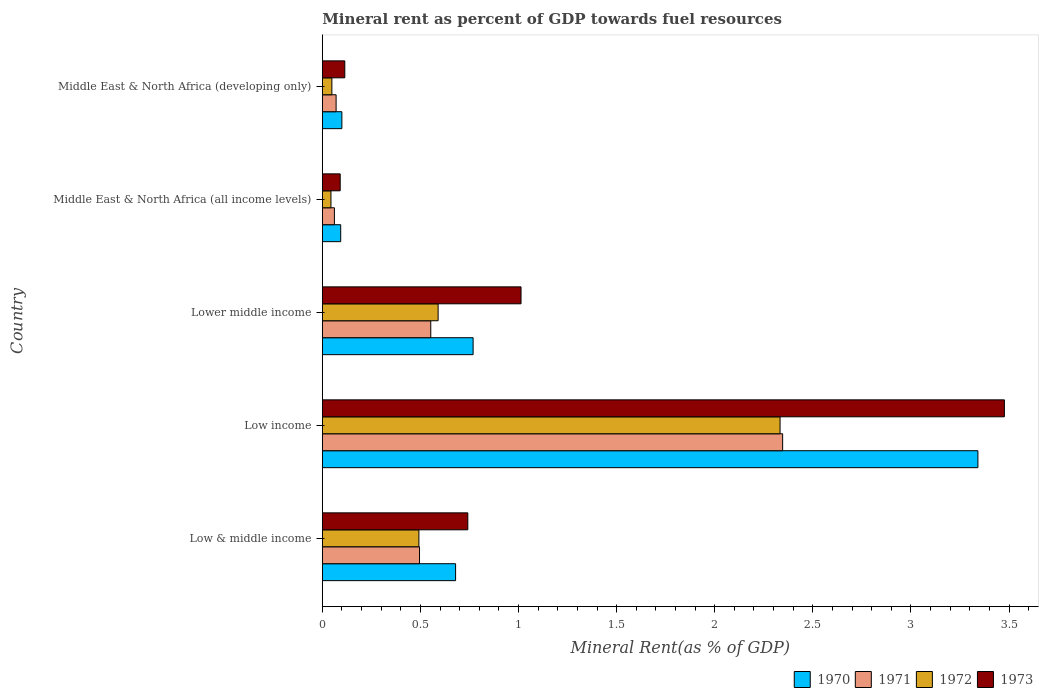How many different coloured bars are there?
Provide a short and direct response. 4. Are the number of bars per tick equal to the number of legend labels?
Your response must be concise. Yes. How many bars are there on the 3rd tick from the top?
Your response must be concise. 4. How many bars are there on the 5th tick from the bottom?
Offer a very short reply. 4. What is the label of the 1st group of bars from the top?
Keep it short and to the point. Middle East & North Africa (developing only). What is the mineral rent in 1972 in Low & middle income?
Offer a terse response. 0.49. Across all countries, what is the maximum mineral rent in 1972?
Offer a very short reply. 2.33. Across all countries, what is the minimum mineral rent in 1973?
Ensure brevity in your answer.  0.09. In which country was the mineral rent in 1971 minimum?
Provide a short and direct response. Middle East & North Africa (all income levels). What is the total mineral rent in 1971 in the graph?
Your response must be concise. 3.53. What is the difference between the mineral rent in 1970 in Low income and that in Lower middle income?
Provide a succinct answer. 2.57. What is the difference between the mineral rent in 1973 in Low income and the mineral rent in 1972 in Low & middle income?
Your response must be concise. 2.98. What is the average mineral rent in 1972 per country?
Offer a terse response. 0.7. What is the difference between the mineral rent in 1970 and mineral rent in 1972 in Middle East & North Africa (all income levels)?
Your answer should be compact. 0.05. What is the ratio of the mineral rent in 1972 in Low income to that in Middle East & North Africa (developing only)?
Provide a succinct answer. 47.95. Is the difference between the mineral rent in 1970 in Low income and Middle East & North Africa (all income levels) greater than the difference between the mineral rent in 1972 in Low income and Middle East & North Africa (all income levels)?
Offer a terse response. Yes. What is the difference between the highest and the second highest mineral rent in 1973?
Give a very brief answer. 2.46. What is the difference between the highest and the lowest mineral rent in 1973?
Your answer should be very brief. 3.39. Is the sum of the mineral rent in 1973 in Low & middle income and Low income greater than the maximum mineral rent in 1972 across all countries?
Offer a very short reply. Yes. What does the 3rd bar from the bottom in Middle East & North Africa (developing only) represents?
Offer a terse response. 1972. How many bars are there?
Provide a short and direct response. 20. Are all the bars in the graph horizontal?
Make the answer very short. Yes. How many countries are there in the graph?
Provide a short and direct response. 5. Does the graph contain any zero values?
Provide a short and direct response. No. Does the graph contain grids?
Offer a terse response. No. Where does the legend appear in the graph?
Provide a short and direct response. Bottom right. How many legend labels are there?
Ensure brevity in your answer.  4. How are the legend labels stacked?
Your response must be concise. Horizontal. What is the title of the graph?
Offer a terse response. Mineral rent as percent of GDP towards fuel resources. What is the label or title of the X-axis?
Give a very brief answer. Mineral Rent(as % of GDP). What is the label or title of the Y-axis?
Give a very brief answer. Country. What is the Mineral Rent(as % of GDP) of 1970 in Low & middle income?
Your response must be concise. 0.68. What is the Mineral Rent(as % of GDP) of 1971 in Low & middle income?
Your answer should be compact. 0.5. What is the Mineral Rent(as % of GDP) of 1972 in Low & middle income?
Your response must be concise. 0.49. What is the Mineral Rent(as % of GDP) in 1973 in Low & middle income?
Keep it short and to the point. 0.74. What is the Mineral Rent(as % of GDP) of 1970 in Low income?
Ensure brevity in your answer.  3.34. What is the Mineral Rent(as % of GDP) in 1971 in Low income?
Keep it short and to the point. 2.35. What is the Mineral Rent(as % of GDP) in 1972 in Low income?
Make the answer very short. 2.33. What is the Mineral Rent(as % of GDP) of 1973 in Low income?
Keep it short and to the point. 3.48. What is the Mineral Rent(as % of GDP) of 1970 in Lower middle income?
Ensure brevity in your answer.  0.77. What is the Mineral Rent(as % of GDP) in 1971 in Lower middle income?
Your answer should be very brief. 0.55. What is the Mineral Rent(as % of GDP) in 1972 in Lower middle income?
Provide a succinct answer. 0.59. What is the Mineral Rent(as % of GDP) in 1973 in Lower middle income?
Provide a succinct answer. 1.01. What is the Mineral Rent(as % of GDP) of 1970 in Middle East & North Africa (all income levels)?
Offer a very short reply. 0.09. What is the Mineral Rent(as % of GDP) in 1971 in Middle East & North Africa (all income levels)?
Offer a very short reply. 0.06. What is the Mineral Rent(as % of GDP) in 1972 in Middle East & North Africa (all income levels)?
Provide a short and direct response. 0.04. What is the Mineral Rent(as % of GDP) of 1973 in Middle East & North Africa (all income levels)?
Your response must be concise. 0.09. What is the Mineral Rent(as % of GDP) of 1970 in Middle East & North Africa (developing only)?
Provide a short and direct response. 0.1. What is the Mineral Rent(as % of GDP) of 1971 in Middle East & North Africa (developing only)?
Provide a succinct answer. 0.07. What is the Mineral Rent(as % of GDP) of 1972 in Middle East & North Africa (developing only)?
Make the answer very short. 0.05. What is the Mineral Rent(as % of GDP) of 1973 in Middle East & North Africa (developing only)?
Provide a succinct answer. 0.11. Across all countries, what is the maximum Mineral Rent(as % of GDP) in 1970?
Your answer should be very brief. 3.34. Across all countries, what is the maximum Mineral Rent(as % of GDP) in 1971?
Keep it short and to the point. 2.35. Across all countries, what is the maximum Mineral Rent(as % of GDP) in 1972?
Provide a succinct answer. 2.33. Across all countries, what is the maximum Mineral Rent(as % of GDP) of 1973?
Offer a very short reply. 3.48. Across all countries, what is the minimum Mineral Rent(as % of GDP) in 1970?
Offer a very short reply. 0.09. Across all countries, what is the minimum Mineral Rent(as % of GDP) of 1971?
Provide a short and direct response. 0.06. Across all countries, what is the minimum Mineral Rent(as % of GDP) of 1972?
Ensure brevity in your answer.  0.04. Across all countries, what is the minimum Mineral Rent(as % of GDP) in 1973?
Provide a succinct answer. 0.09. What is the total Mineral Rent(as % of GDP) in 1970 in the graph?
Make the answer very short. 4.98. What is the total Mineral Rent(as % of GDP) of 1971 in the graph?
Provide a succinct answer. 3.53. What is the total Mineral Rent(as % of GDP) in 1972 in the graph?
Your answer should be compact. 3.51. What is the total Mineral Rent(as % of GDP) in 1973 in the graph?
Ensure brevity in your answer.  5.44. What is the difference between the Mineral Rent(as % of GDP) in 1970 in Low & middle income and that in Low income?
Offer a very short reply. -2.66. What is the difference between the Mineral Rent(as % of GDP) of 1971 in Low & middle income and that in Low income?
Provide a short and direct response. -1.85. What is the difference between the Mineral Rent(as % of GDP) of 1972 in Low & middle income and that in Low income?
Ensure brevity in your answer.  -1.84. What is the difference between the Mineral Rent(as % of GDP) in 1973 in Low & middle income and that in Low income?
Your response must be concise. -2.73. What is the difference between the Mineral Rent(as % of GDP) of 1970 in Low & middle income and that in Lower middle income?
Provide a succinct answer. -0.09. What is the difference between the Mineral Rent(as % of GDP) of 1971 in Low & middle income and that in Lower middle income?
Your response must be concise. -0.06. What is the difference between the Mineral Rent(as % of GDP) in 1972 in Low & middle income and that in Lower middle income?
Offer a terse response. -0.1. What is the difference between the Mineral Rent(as % of GDP) in 1973 in Low & middle income and that in Lower middle income?
Make the answer very short. -0.27. What is the difference between the Mineral Rent(as % of GDP) in 1970 in Low & middle income and that in Middle East & North Africa (all income levels)?
Offer a very short reply. 0.59. What is the difference between the Mineral Rent(as % of GDP) in 1971 in Low & middle income and that in Middle East & North Africa (all income levels)?
Provide a short and direct response. 0.43. What is the difference between the Mineral Rent(as % of GDP) in 1972 in Low & middle income and that in Middle East & North Africa (all income levels)?
Your answer should be compact. 0.45. What is the difference between the Mineral Rent(as % of GDP) in 1973 in Low & middle income and that in Middle East & North Africa (all income levels)?
Keep it short and to the point. 0.65. What is the difference between the Mineral Rent(as % of GDP) of 1970 in Low & middle income and that in Middle East & North Africa (developing only)?
Provide a short and direct response. 0.58. What is the difference between the Mineral Rent(as % of GDP) in 1971 in Low & middle income and that in Middle East & North Africa (developing only)?
Provide a succinct answer. 0.43. What is the difference between the Mineral Rent(as % of GDP) of 1972 in Low & middle income and that in Middle East & North Africa (developing only)?
Your response must be concise. 0.44. What is the difference between the Mineral Rent(as % of GDP) in 1973 in Low & middle income and that in Middle East & North Africa (developing only)?
Your response must be concise. 0.63. What is the difference between the Mineral Rent(as % of GDP) of 1970 in Low income and that in Lower middle income?
Offer a terse response. 2.57. What is the difference between the Mineral Rent(as % of GDP) in 1971 in Low income and that in Lower middle income?
Provide a short and direct response. 1.79. What is the difference between the Mineral Rent(as % of GDP) of 1972 in Low income and that in Lower middle income?
Keep it short and to the point. 1.74. What is the difference between the Mineral Rent(as % of GDP) in 1973 in Low income and that in Lower middle income?
Give a very brief answer. 2.46. What is the difference between the Mineral Rent(as % of GDP) in 1970 in Low income and that in Middle East & North Africa (all income levels)?
Your answer should be very brief. 3.25. What is the difference between the Mineral Rent(as % of GDP) in 1971 in Low income and that in Middle East & North Africa (all income levels)?
Ensure brevity in your answer.  2.28. What is the difference between the Mineral Rent(as % of GDP) of 1972 in Low income and that in Middle East & North Africa (all income levels)?
Make the answer very short. 2.29. What is the difference between the Mineral Rent(as % of GDP) in 1973 in Low income and that in Middle East & North Africa (all income levels)?
Keep it short and to the point. 3.39. What is the difference between the Mineral Rent(as % of GDP) of 1970 in Low income and that in Middle East & North Africa (developing only)?
Provide a succinct answer. 3.24. What is the difference between the Mineral Rent(as % of GDP) of 1971 in Low income and that in Middle East & North Africa (developing only)?
Your answer should be compact. 2.28. What is the difference between the Mineral Rent(as % of GDP) of 1972 in Low income and that in Middle East & North Africa (developing only)?
Make the answer very short. 2.28. What is the difference between the Mineral Rent(as % of GDP) of 1973 in Low income and that in Middle East & North Africa (developing only)?
Your response must be concise. 3.36. What is the difference between the Mineral Rent(as % of GDP) of 1970 in Lower middle income and that in Middle East & North Africa (all income levels)?
Your answer should be very brief. 0.67. What is the difference between the Mineral Rent(as % of GDP) of 1971 in Lower middle income and that in Middle East & North Africa (all income levels)?
Your answer should be very brief. 0.49. What is the difference between the Mineral Rent(as % of GDP) in 1972 in Lower middle income and that in Middle East & North Africa (all income levels)?
Make the answer very short. 0.55. What is the difference between the Mineral Rent(as % of GDP) in 1973 in Lower middle income and that in Middle East & North Africa (all income levels)?
Ensure brevity in your answer.  0.92. What is the difference between the Mineral Rent(as % of GDP) of 1970 in Lower middle income and that in Middle East & North Africa (developing only)?
Provide a short and direct response. 0.67. What is the difference between the Mineral Rent(as % of GDP) in 1971 in Lower middle income and that in Middle East & North Africa (developing only)?
Ensure brevity in your answer.  0.48. What is the difference between the Mineral Rent(as % of GDP) in 1972 in Lower middle income and that in Middle East & North Africa (developing only)?
Provide a succinct answer. 0.54. What is the difference between the Mineral Rent(as % of GDP) of 1973 in Lower middle income and that in Middle East & North Africa (developing only)?
Provide a short and direct response. 0.9. What is the difference between the Mineral Rent(as % of GDP) of 1970 in Middle East & North Africa (all income levels) and that in Middle East & North Africa (developing only)?
Your response must be concise. -0.01. What is the difference between the Mineral Rent(as % of GDP) of 1971 in Middle East & North Africa (all income levels) and that in Middle East & North Africa (developing only)?
Ensure brevity in your answer.  -0.01. What is the difference between the Mineral Rent(as % of GDP) of 1972 in Middle East & North Africa (all income levels) and that in Middle East & North Africa (developing only)?
Keep it short and to the point. -0. What is the difference between the Mineral Rent(as % of GDP) of 1973 in Middle East & North Africa (all income levels) and that in Middle East & North Africa (developing only)?
Your answer should be compact. -0.02. What is the difference between the Mineral Rent(as % of GDP) in 1970 in Low & middle income and the Mineral Rent(as % of GDP) in 1971 in Low income?
Make the answer very short. -1.67. What is the difference between the Mineral Rent(as % of GDP) of 1970 in Low & middle income and the Mineral Rent(as % of GDP) of 1972 in Low income?
Provide a succinct answer. -1.65. What is the difference between the Mineral Rent(as % of GDP) of 1970 in Low & middle income and the Mineral Rent(as % of GDP) of 1973 in Low income?
Offer a very short reply. -2.8. What is the difference between the Mineral Rent(as % of GDP) in 1971 in Low & middle income and the Mineral Rent(as % of GDP) in 1972 in Low income?
Your response must be concise. -1.84. What is the difference between the Mineral Rent(as % of GDP) of 1971 in Low & middle income and the Mineral Rent(as % of GDP) of 1973 in Low income?
Provide a short and direct response. -2.98. What is the difference between the Mineral Rent(as % of GDP) of 1972 in Low & middle income and the Mineral Rent(as % of GDP) of 1973 in Low income?
Keep it short and to the point. -2.98. What is the difference between the Mineral Rent(as % of GDP) in 1970 in Low & middle income and the Mineral Rent(as % of GDP) in 1971 in Lower middle income?
Your answer should be compact. 0.13. What is the difference between the Mineral Rent(as % of GDP) in 1970 in Low & middle income and the Mineral Rent(as % of GDP) in 1972 in Lower middle income?
Offer a terse response. 0.09. What is the difference between the Mineral Rent(as % of GDP) of 1970 in Low & middle income and the Mineral Rent(as % of GDP) of 1973 in Lower middle income?
Your answer should be compact. -0.33. What is the difference between the Mineral Rent(as % of GDP) of 1971 in Low & middle income and the Mineral Rent(as % of GDP) of 1972 in Lower middle income?
Ensure brevity in your answer.  -0.09. What is the difference between the Mineral Rent(as % of GDP) of 1971 in Low & middle income and the Mineral Rent(as % of GDP) of 1973 in Lower middle income?
Offer a very short reply. -0.52. What is the difference between the Mineral Rent(as % of GDP) in 1972 in Low & middle income and the Mineral Rent(as % of GDP) in 1973 in Lower middle income?
Offer a very short reply. -0.52. What is the difference between the Mineral Rent(as % of GDP) of 1970 in Low & middle income and the Mineral Rent(as % of GDP) of 1971 in Middle East & North Africa (all income levels)?
Keep it short and to the point. 0.62. What is the difference between the Mineral Rent(as % of GDP) in 1970 in Low & middle income and the Mineral Rent(as % of GDP) in 1972 in Middle East & North Africa (all income levels)?
Your response must be concise. 0.64. What is the difference between the Mineral Rent(as % of GDP) in 1970 in Low & middle income and the Mineral Rent(as % of GDP) in 1973 in Middle East & North Africa (all income levels)?
Your answer should be very brief. 0.59. What is the difference between the Mineral Rent(as % of GDP) of 1971 in Low & middle income and the Mineral Rent(as % of GDP) of 1972 in Middle East & North Africa (all income levels)?
Your response must be concise. 0.45. What is the difference between the Mineral Rent(as % of GDP) of 1971 in Low & middle income and the Mineral Rent(as % of GDP) of 1973 in Middle East & North Africa (all income levels)?
Provide a succinct answer. 0.4. What is the difference between the Mineral Rent(as % of GDP) of 1972 in Low & middle income and the Mineral Rent(as % of GDP) of 1973 in Middle East & North Africa (all income levels)?
Provide a succinct answer. 0.4. What is the difference between the Mineral Rent(as % of GDP) of 1970 in Low & middle income and the Mineral Rent(as % of GDP) of 1971 in Middle East & North Africa (developing only)?
Provide a short and direct response. 0.61. What is the difference between the Mineral Rent(as % of GDP) of 1970 in Low & middle income and the Mineral Rent(as % of GDP) of 1972 in Middle East & North Africa (developing only)?
Provide a short and direct response. 0.63. What is the difference between the Mineral Rent(as % of GDP) in 1970 in Low & middle income and the Mineral Rent(as % of GDP) in 1973 in Middle East & North Africa (developing only)?
Keep it short and to the point. 0.56. What is the difference between the Mineral Rent(as % of GDP) in 1971 in Low & middle income and the Mineral Rent(as % of GDP) in 1972 in Middle East & North Africa (developing only)?
Ensure brevity in your answer.  0.45. What is the difference between the Mineral Rent(as % of GDP) of 1971 in Low & middle income and the Mineral Rent(as % of GDP) of 1973 in Middle East & North Africa (developing only)?
Your answer should be very brief. 0.38. What is the difference between the Mineral Rent(as % of GDP) in 1972 in Low & middle income and the Mineral Rent(as % of GDP) in 1973 in Middle East & North Africa (developing only)?
Keep it short and to the point. 0.38. What is the difference between the Mineral Rent(as % of GDP) in 1970 in Low income and the Mineral Rent(as % of GDP) in 1971 in Lower middle income?
Keep it short and to the point. 2.79. What is the difference between the Mineral Rent(as % of GDP) in 1970 in Low income and the Mineral Rent(as % of GDP) in 1972 in Lower middle income?
Your answer should be compact. 2.75. What is the difference between the Mineral Rent(as % of GDP) of 1970 in Low income and the Mineral Rent(as % of GDP) of 1973 in Lower middle income?
Make the answer very short. 2.33. What is the difference between the Mineral Rent(as % of GDP) in 1971 in Low income and the Mineral Rent(as % of GDP) in 1972 in Lower middle income?
Your response must be concise. 1.76. What is the difference between the Mineral Rent(as % of GDP) of 1971 in Low income and the Mineral Rent(as % of GDP) of 1973 in Lower middle income?
Ensure brevity in your answer.  1.33. What is the difference between the Mineral Rent(as % of GDP) in 1972 in Low income and the Mineral Rent(as % of GDP) in 1973 in Lower middle income?
Make the answer very short. 1.32. What is the difference between the Mineral Rent(as % of GDP) in 1970 in Low income and the Mineral Rent(as % of GDP) in 1971 in Middle East & North Africa (all income levels)?
Make the answer very short. 3.28. What is the difference between the Mineral Rent(as % of GDP) in 1970 in Low income and the Mineral Rent(as % of GDP) in 1972 in Middle East & North Africa (all income levels)?
Provide a succinct answer. 3.3. What is the difference between the Mineral Rent(as % of GDP) of 1970 in Low income and the Mineral Rent(as % of GDP) of 1973 in Middle East & North Africa (all income levels)?
Your answer should be compact. 3.25. What is the difference between the Mineral Rent(as % of GDP) in 1971 in Low income and the Mineral Rent(as % of GDP) in 1972 in Middle East & North Africa (all income levels)?
Provide a short and direct response. 2.3. What is the difference between the Mineral Rent(as % of GDP) of 1971 in Low income and the Mineral Rent(as % of GDP) of 1973 in Middle East & North Africa (all income levels)?
Provide a short and direct response. 2.26. What is the difference between the Mineral Rent(as % of GDP) in 1972 in Low income and the Mineral Rent(as % of GDP) in 1973 in Middle East & North Africa (all income levels)?
Your answer should be compact. 2.24. What is the difference between the Mineral Rent(as % of GDP) of 1970 in Low income and the Mineral Rent(as % of GDP) of 1971 in Middle East & North Africa (developing only)?
Give a very brief answer. 3.27. What is the difference between the Mineral Rent(as % of GDP) of 1970 in Low income and the Mineral Rent(as % of GDP) of 1972 in Middle East & North Africa (developing only)?
Offer a terse response. 3.29. What is the difference between the Mineral Rent(as % of GDP) of 1970 in Low income and the Mineral Rent(as % of GDP) of 1973 in Middle East & North Africa (developing only)?
Ensure brevity in your answer.  3.23. What is the difference between the Mineral Rent(as % of GDP) in 1971 in Low income and the Mineral Rent(as % of GDP) in 1972 in Middle East & North Africa (developing only)?
Your answer should be compact. 2.3. What is the difference between the Mineral Rent(as % of GDP) of 1971 in Low income and the Mineral Rent(as % of GDP) of 1973 in Middle East & North Africa (developing only)?
Give a very brief answer. 2.23. What is the difference between the Mineral Rent(as % of GDP) in 1972 in Low income and the Mineral Rent(as % of GDP) in 1973 in Middle East & North Africa (developing only)?
Your response must be concise. 2.22. What is the difference between the Mineral Rent(as % of GDP) in 1970 in Lower middle income and the Mineral Rent(as % of GDP) in 1971 in Middle East & North Africa (all income levels)?
Your answer should be very brief. 0.71. What is the difference between the Mineral Rent(as % of GDP) in 1970 in Lower middle income and the Mineral Rent(as % of GDP) in 1972 in Middle East & North Africa (all income levels)?
Keep it short and to the point. 0.72. What is the difference between the Mineral Rent(as % of GDP) in 1970 in Lower middle income and the Mineral Rent(as % of GDP) in 1973 in Middle East & North Africa (all income levels)?
Give a very brief answer. 0.68. What is the difference between the Mineral Rent(as % of GDP) in 1971 in Lower middle income and the Mineral Rent(as % of GDP) in 1972 in Middle East & North Africa (all income levels)?
Offer a very short reply. 0.51. What is the difference between the Mineral Rent(as % of GDP) of 1971 in Lower middle income and the Mineral Rent(as % of GDP) of 1973 in Middle East & North Africa (all income levels)?
Keep it short and to the point. 0.46. What is the difference between the Mineral Rent(as % of GDP) in 1972 in Lower middle income and the Mineral Rent(as % of GDP) in 1973 in Middle East & North Africa (all income levels)?
Provide a short and direct response. 0.5. What is the difference between the Mineral Rent(as % of GDP) of 1970 in Lower middle income and the Mineral Rent(as % of GDP) of 1971 in Middle East & North Africa (developing only)?
Provide a succinct answer. 0.7. What is the difference between the Mineral Rent(as % of GDP) in 1970 in Lower middle income and the Mineral Rent(as % of GDP) in 1972 in Middle East & North Africa (developing only)?
Your answer should be compact. 0.72. What is the difference between the Mineral Rent(as % of GDP) in 1970 in Lower middle income and the Mineral Rent(as % of GDP) in 1973 in Middle East & North Africa (developing only)?
Your answer should be compact. 0.65. What is the difference between the Mineral Rent(as % of GDP) in 1971 in Lower middle income and the Mineral Rent(as % of GDP) in 1972 in Middle East & North Africa (developing only)?
Offer a very short reply. 0.5. What is the difference between the Mineral Rent(as % of GDP) in 1971 in Lower middle income and the Mineral Rent(as % of GDP) in 1973 in Middle East & North Africa (developing only)?
Ensure brevity in your answer.  0.44. What is the difference between the Mineral Rent(as % of GDP) in 1972 in Lower middle income and the Mineral Rent(as % of GDP) in 1973 in Middle East & North Africa (developing only)?
Your answer should be very brief. 0.48. What is the difference between the Mineral Rent(as % of GDP) of 1970 in Middle East & North Africa (all income levels) and the Mineral Rent(as % of GDP) of 1971 in Middle East & North Africa (developing only)?
Offer a very short reply. 0.02. What is the difference between the Mineral Rent(as % of GDP) of 1970 in Middle East & North Africa (all income levels) and the Mineral Rent(as % of GDP) of 1972 in Middle East & North Africa (developing only)?
Offer a very short reply. 0.04. What is the difference between the Mineral Rent(as % of GDP) of 1970 in Middle East & North Africa (all income levels) and the Mineral Rent(as % of GDP) of 1973 in Middle East & North Africa (developing only)?
Ensure brevity in your answer.  -0.02. What is the difference between the Mineral Rent(as % of GDP) of 1971 in Middle East & North Africa (all income levels) and the Mineral Rent(as % of GDP) of 1972 in Middle East & North Africa (developing only)?
Provide a short and direct response. 0.01. What is the difference between the Mineral Rent(as % of GDP) of 1971 in Middle East & North Africa (all income levels) and the Mineral Rent(as % of GDP) of 1973 in Middle East & North Africa (developing only)?
Ensure brevity in your answer.  -0.05. What is the difference between the Mineral Rent(as % of GDP) of 1972 in Middle East & North Africa (all income levels) and the Mineral Rent(as % of GDP) of 1973 in Middle East & North Africa (developing only)?
Keep it short and to the point. -0.07. What is the average Mineral Rent(as % of GDP) of 1971 per country?
Give a very brief answer. 0.71. What is the average Mineral Rent(as % of GDP) in 1972 per country?
Give a very brief answer. 0.7. What is the average Mineral Rent(as % of GDP) in 1973 per country?
Give a very brief answer. 1.09. What is the difference between the Mineral Rent(as % of GDP) of 1970 and Mineral Rent(as % of GDP) of 1971 in Low & middle income?
Provide a succinct answer. 0.18. What is the difference between the Mineral Rent(as % of GDP) of 1970 and Mineral Rent(as % of GDP) of 1972 in Low & middle income?
Your answer should be very brief. 0.19. What is the difference between the Mineral Rent(as % of GDP) of 1970 and Mineral Rent(as % of GDP) of 1973 in Low & middle income?
Give a very brief answer. -0.06. What is the difference between the Mineral Rent(as % of GDP) in 1971 and Mineral Rent(as % of GDP) in 1972 in Low & middle income?
Provide a short and direct response. 0. What is the difference between the Mineral Rent(as % of GDP) in 1971 and Mineral Rent(as % of GDP) in 1973 in Low & middle income?
Provide a short and direct response. -0.25. What is the difference between the Mineral Rent(as % of GDP) in 1972 and Mineral Rent(as % of GDP) in 1973 in Low & middle income?
Provide a succinct answer. -0.25. What is the difference between the Mineral Rent(as % of GDP) in 1970 and Mineral Rent(as % of GDP) in 1972 in Low income?
Provide a succinct answer. 1.01. What is the difference between the Mineral Rent(as % of GDP) of 1970 and Mineral Rent(as % of GDP) of 1973 in Low income?
Offer a terse response. -0.14. What is the difference between the Mineral Rent(as % of GDP) of 1971 and Mineral Rent(as % of GDP) of 1972 in Low income?
Keep it short and to the point. 0.01. What is the difference between the Mineral Rent(as % of GDP) of 1971 and Mineral Rent(as % of GDP) of 1973 in Low income?
Make the answer very short. -1.13. What is the difference between the Mineral Rent(as % of GDP) of 1972 and Mineral Rent(as % of GDP) of 1973 in Low income?
Your answer should be compact. -1.14. What is the difference between the Mineral Rent(as % of GDP) in 1970 and Mineral Rent(as % of GDP) in 1971 in Lower middle income?
Your answer should be very brief. 0.22. What is the difference between the Mineral Rent(as % of GDP) of 1970 and Mineral Rent(as % of GDP) of 1972 in Lower middle income?
Offer a terse response. 0.18. What is the difference between the Mineral Rent(as % of GDP) in 1970 and Mineral Rent(as % of GDP) in 1973 in Lower middle income?
Your response must be concise. -0.24. What is the difference between the Mineral Rent(as % of GDP) of 1971 and Mineral Rent(as % of GDP) of 1972 in Lower middle income?
Your response must be concise. -0.04. What is the difference between the Mineral Rent(as % of GDP) of 1971 and Mineral Rent(as % of GDP) of 1973 in Lower middle income?
Keep it short and to the point. -0.46. What is the difference between the Mineral Rent(as % of GDP) in 1972 and Mineral Rent(as % of GDP) in 1973 in Lower middle income?
Your response must be concise. -0.42. What is the difference between the Mineral Rent(as % of GDP) in 1970 and Mineral Rent(as % of GDP) in 1971 in Middle East & North Africa (all income levels)?
Offer a very short reply. 0.03. What is the difference between the Mineral Rent(as % of GDP) of 1970 and Mineral Rent(as % of GDP) of 1972 in Middle East & North Africa (all income levels)?
Offer a very short reply. 0.05. What is the difference between the Mineral Rent(as % of GDP) of 1970 and Mineral Rent(as % of GDP) of 1973 in Middle East & North Africa (all income levels)?
Give a very brief answer. 0. What is the difference between the Mineral Rent(as % of GDP) of 1971 and Mineral Rent(as % of GDP) of 1972 in Middle East & North Africa (all income levels)?
Offer a very short reply. 0.02. What is the difference between the Mineral Rent(as % of GDP) of 1971 and Mineral Rent(as % of GDP) of 1973 in Middle East & North Africa (all income levels)?
Ensure brevity in your answer.  -0.03. What is the difference between the Mineral Rent(as % of GDP) of 1972 and Mineral Rent(as % of GDP) of 1973 in Middle East & North Africa (all income levels)?
Your answer should be compact. -0.05. What is the difference between the Mineral Rent(as % of GDP) of 1970 and Mineral Rent(as % of GDP) of 1971 in Middle East & North Africa (developing only)?
Offer a terse response. 0.03. What is the difference between the Mineral Rent(as % of GDP) of 1970 and Mineral Rent(as % of GDP) of 1972 in Middle East & North Africa (developing only)?
Your response must be concise. 0.05. What is the difference between the Mineral Rent(as % of GDP) in 1970 and Mineral Rent(as % of GDP) in 1973 in Middle East & North Africa (developing only)?
Your answer should be compact. -0.01. What is the difference between the Mineral Rent(as % of GDP) in 1971 and Mineral Rent(as % of GDP) in 1972 in Middle East & North Africa (developing only)?
Make the answer very short. 0.02. What is the difference between the Mineral Rent(as % of GDP) in 1971 and Mineral Rent(as % of GDP) in 1973 in Middle East & North Africa (developing only)?
Keep it short and to the point. -0.04. What is the difference between the Mineral Rent(as % of GDP) in 1972 and Mineral Rent(as % of GDP) in 1973 in Middle East & North Africa (developing only)?
Your answer should be very brief. -0.07. What is the ratio of the Mineral Rent(as % of GDP) in 1970 in Low & middle income to that in Low income?
Provide a succinct answer. 0.2. What is the ratio of the Mineral Rent(as % of GDP) of 1971 in Low & middle income to that in Low income?
Keep it short and to the point. 0.21. What is the ratio of the Mineral Rent(as % of GDP) in 1972 in Low & middle income to that in Low income?
Provide a short and direct response. 0.21. What is the ratio of the Mineral Rent(as % of GDP) of 1973 in Low & middle income to that in Low income?
Provide a short and direct response. 0.21. What is the ratio of the Mineral Rent(as % of GDP) of 1970 in Low & middle income to that in Lower middle income?
Your answer should be compact. 0.88. What is the ratio of the Mineral Rent(as % of GDP) in 1971 in Low & middle income to that in Lower middle income?
Keep it short and to the point. 0.9. What is the ratio of the Mineral Rent(as % of GDP) of 1972 in Low & middle income to that in Lower middle income?
Make the answer very short. 0.83. What is the ratio of the Mineral Rent(as % of GDP) in 1973 in Low & middle income to that in Lower middle income?
Your answer should be very brief. 0.73. What is the ratio of the Mineral Rent(as % of GDP) in 1970 in Low & middle income to that in Middle East & North Africa (all income levels)?
Offer a very short reply. 7.25. What is the ratio of the Mineral Rent(as % of GDP) of 1971 in Low & middle income to that in Middle East & North Africa (all income levels)?
Give a very brief answer. 8.05. What is the ratio of the Mineral Rent(as % of GDP) in 1972 in Low & middle income to that in Middle East & North Africa (all income levels)?
Offer a terse response. 11.19. What is the ratio of the Mineral Rent(as % of GDP) in 1973 in Low & middle income to that in Middle East & North Africa (all income levels)?
Keep it short and to the point. 8.14. What is the ratio of the Mineral Rent(as % of GDP) of 1970 in Low & middle income to that in Middle East & North Africa (developing only)?
Your response must be concise. 6.82. What is the ratio of the Mineral Rent(as % of GDP) of 1971 in Low & middle income to that in Middle East & North Africa (developing only)?
Offer a terse response. 7.06. What is the ratio of the Mineral Rent(as % of GDP) in 1972 in Low & middle income to that in Middle East & North Africa (developing only)?
Your answer should be compact. 10.11. What is the ratio of the Mineral Rent(as % of GDP) of 1973 in Low & middle income to that in Middle East & North Africa (developing only)?
Keep it short and to the point. 6.48. What is the ratio of the Mineral Rent(as % of GDP) of 1970 in Low income to that in Lower middle income?
Your response must be concise. 4.35. What is the ratio of the Mineral Rent(as % of GDP) of 1971 in Low income to that in Lower middle income?
Provide a short and direct response. 4.25. What is the ratio of the Mineral Rent(as % of GDP) in 1972 in Low income to that in Lower middle income?
Provide a succinct answer. 3.95. What is the ratio of the Mineral Rent(as % of GDP) of 1973 in Low income to that in Lower middle income?
Offer a terse response. 3.43. What is the ratio of the Mineral Rent(as % of GDP) in 1970 in Low income to that in Middle East & North Africa (all income levels)?
Ensure brevity in your answer.  35.68. What is the ratio of the Mineral Rent(as % of GDP) of 1971 in Low income to that in Middle East & North Africa (all income levels)?
Keep it short and to the point. 38.13. What is the ratio of the Mineral Rent(as % of GDP) in 1972 in Low income to that in Middle East & North Africa (all income levels)?
Your response must be concise. 53.05. What is the ratio of the Mineral Rent(as % of GDP) of 1973 in Low income to that in Middle East & North Africa (all income levels)?
Provide a short and direct response. 38.18. What is the ratio of the Mineral Rent(as % of GDP) in 1970 in Low income to that in Middle East & North Africa (developing only)?
Provide a succinct answer. 33.55. What is the ratio of the Mineral Rent(as % of GDP) in 1971 in Low income to that in Middle East & North Africa (developing only)?
Your answer should be compact. 33.42. What is the ratio of the Mineral Rent(as % of GDP) in 1972 in Low income to that in Middle East & North Africa (developing only)?
Make the answer very short. 47.95. What is the ratio of the Mineral Rent(as % of GDP) in 1973 in Low income to that in Middle East & North Africa (developing only)?
Keep it short and to the point. 30.36. What is the ratio of the Mineral Rent(as % of GDP) in 1970 in Lower middle income to that in Middle East & North Africa (all income levels)?
Keep it short and to the point. 8.21. What is the ratio of the Mineral Rent(as % of GDP) in 1971 in Lower middle income to that in Middle East & North Africa (all income levels)?
Make the answer very short. 8.98. What is the ratio of the Mineral Rent(as % of GDP) of 1972 in Lower middle income to that in Middle East & North Africa (all income levels)?
Keep it short and to the point. 13.42. What is the ratio of the Mineral Rent(as % of GDP) of 1973 in Lower middle income to that in Middle East & North Africa (all income levels)?
Offer a very short reply. 11.12. What is the ratio of the Mineral Rent(as % of GDP) of 1970 in Lower middle income to that in Middle East & North Africa (developing only)?
Give a very brief answer. 7.72. What is the ratio of the Mineral Rent(as % of GDP) in 1971 in Lower middle income to that in Middle East & North Africa (developing only)?
Your answer should be very brief. 7.87. What is the ratio of the Mineral Rent(as % of GDP) of 1972 in Lower middle income to that in Middle East & North Africa (developing only)?
Offer a terse response. 12.13. What is the ratio of the Mineral Rent(as % of GDP) of 1973 in Lower middle income to that in Middle East & North Africa (developing only)?
Offer a very short reply. 8.85. What is the ratio of the Mineral Rent(as % of GDP) in 1970 in Middle East & North Africa (all income levels) to that in Middle East & North Africa (developing only)?
Provide a succinct answer. 0.94. What is the ratio of the Mineral Rent(as % of GDP) in 1971 in Middle East & North Africa (all income levels) to that in Middle East & North Africa (developing only)?
Offer a terse response. 0.88. What is the ratio of the Mineral Rent(as % of GDP) of 1972 in Middle East & North Africa (all income levels) to that in Middle East & North Africa (developing only)?
Offer a very short reply. 0.9. What is the ratio of the Mineral Rent(as % of GDP) in 1973 in Middle East & North Africa (all income levels) to that in Middle East & North Africa (developing only)?
Give a very brief answer. 0.8. What is the difference between the highest and the second highest Mineral Rent(as % of GDP) in 1970?
Provide a short and direct response. 2.57. What is the difference between the highest and the second highest Mineral Rent(as % of GDP) of 1971?
Offer a very short reply. 1.79. What is the difference between the highest and the second highest Mineral Rent(as % of GDP) in 1972?
Your response must be concise. 1.74. What is the difference between the highest and the second highest Mineral Rent(as % of GDP) in 1973?
Ensure brevity in your answer.  2.46. What is the difference between the highest and the lowest Mineral Rent(as % of GDP) of 1970?
Offer a terse response. 3.25. What is the difference between the highest and the lowest Mineral Rent(as % of GDP) in 1971?
Your response must be concise. 2.28. What is the difference between the highest and the lowest Mineral Rent(as % of GDP) of 1972?
Offer a terse response. 2.29. What is the difference between the highest and the lowest Mineral Rent(as % of GDP) of 1973?
Your answer should be very brief. 3.39. 